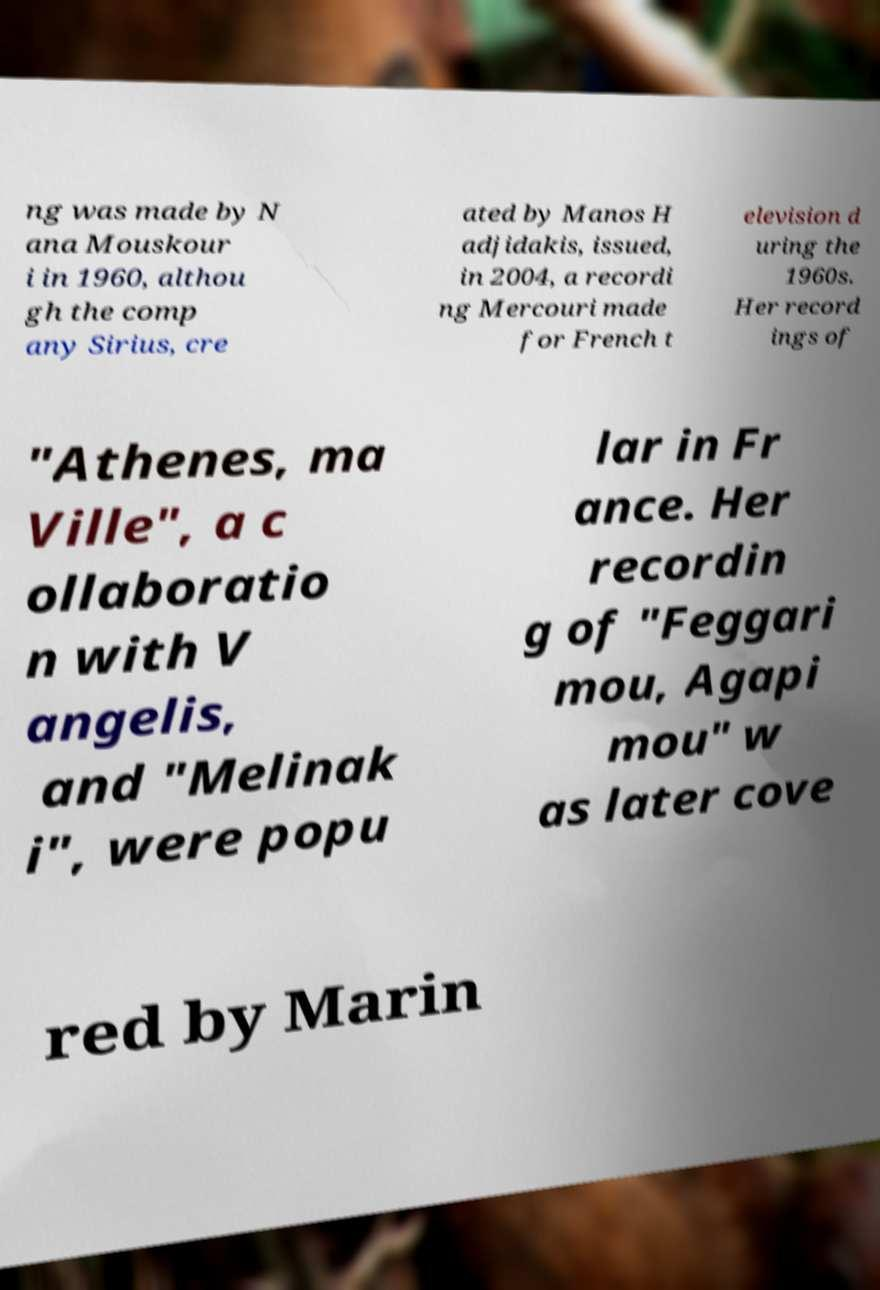I need the written content from this picture converted into text. Can you do that? ng was made by N ana Mouskour i in 1960, althou gh the comp any Sirius, cre ated by Manos H adjidakis, issued, in 2004, a recordi ng Mercouri made for French t elevision d uring the 1960s. Her record ings of "Athenes, ma Ville", a c ollaboratio n with V angelis, and "Melinak i", were popu lar in Fr ance. Her recordin g of "Feggari mou, Agapi mou" w as later cove red by Marin 